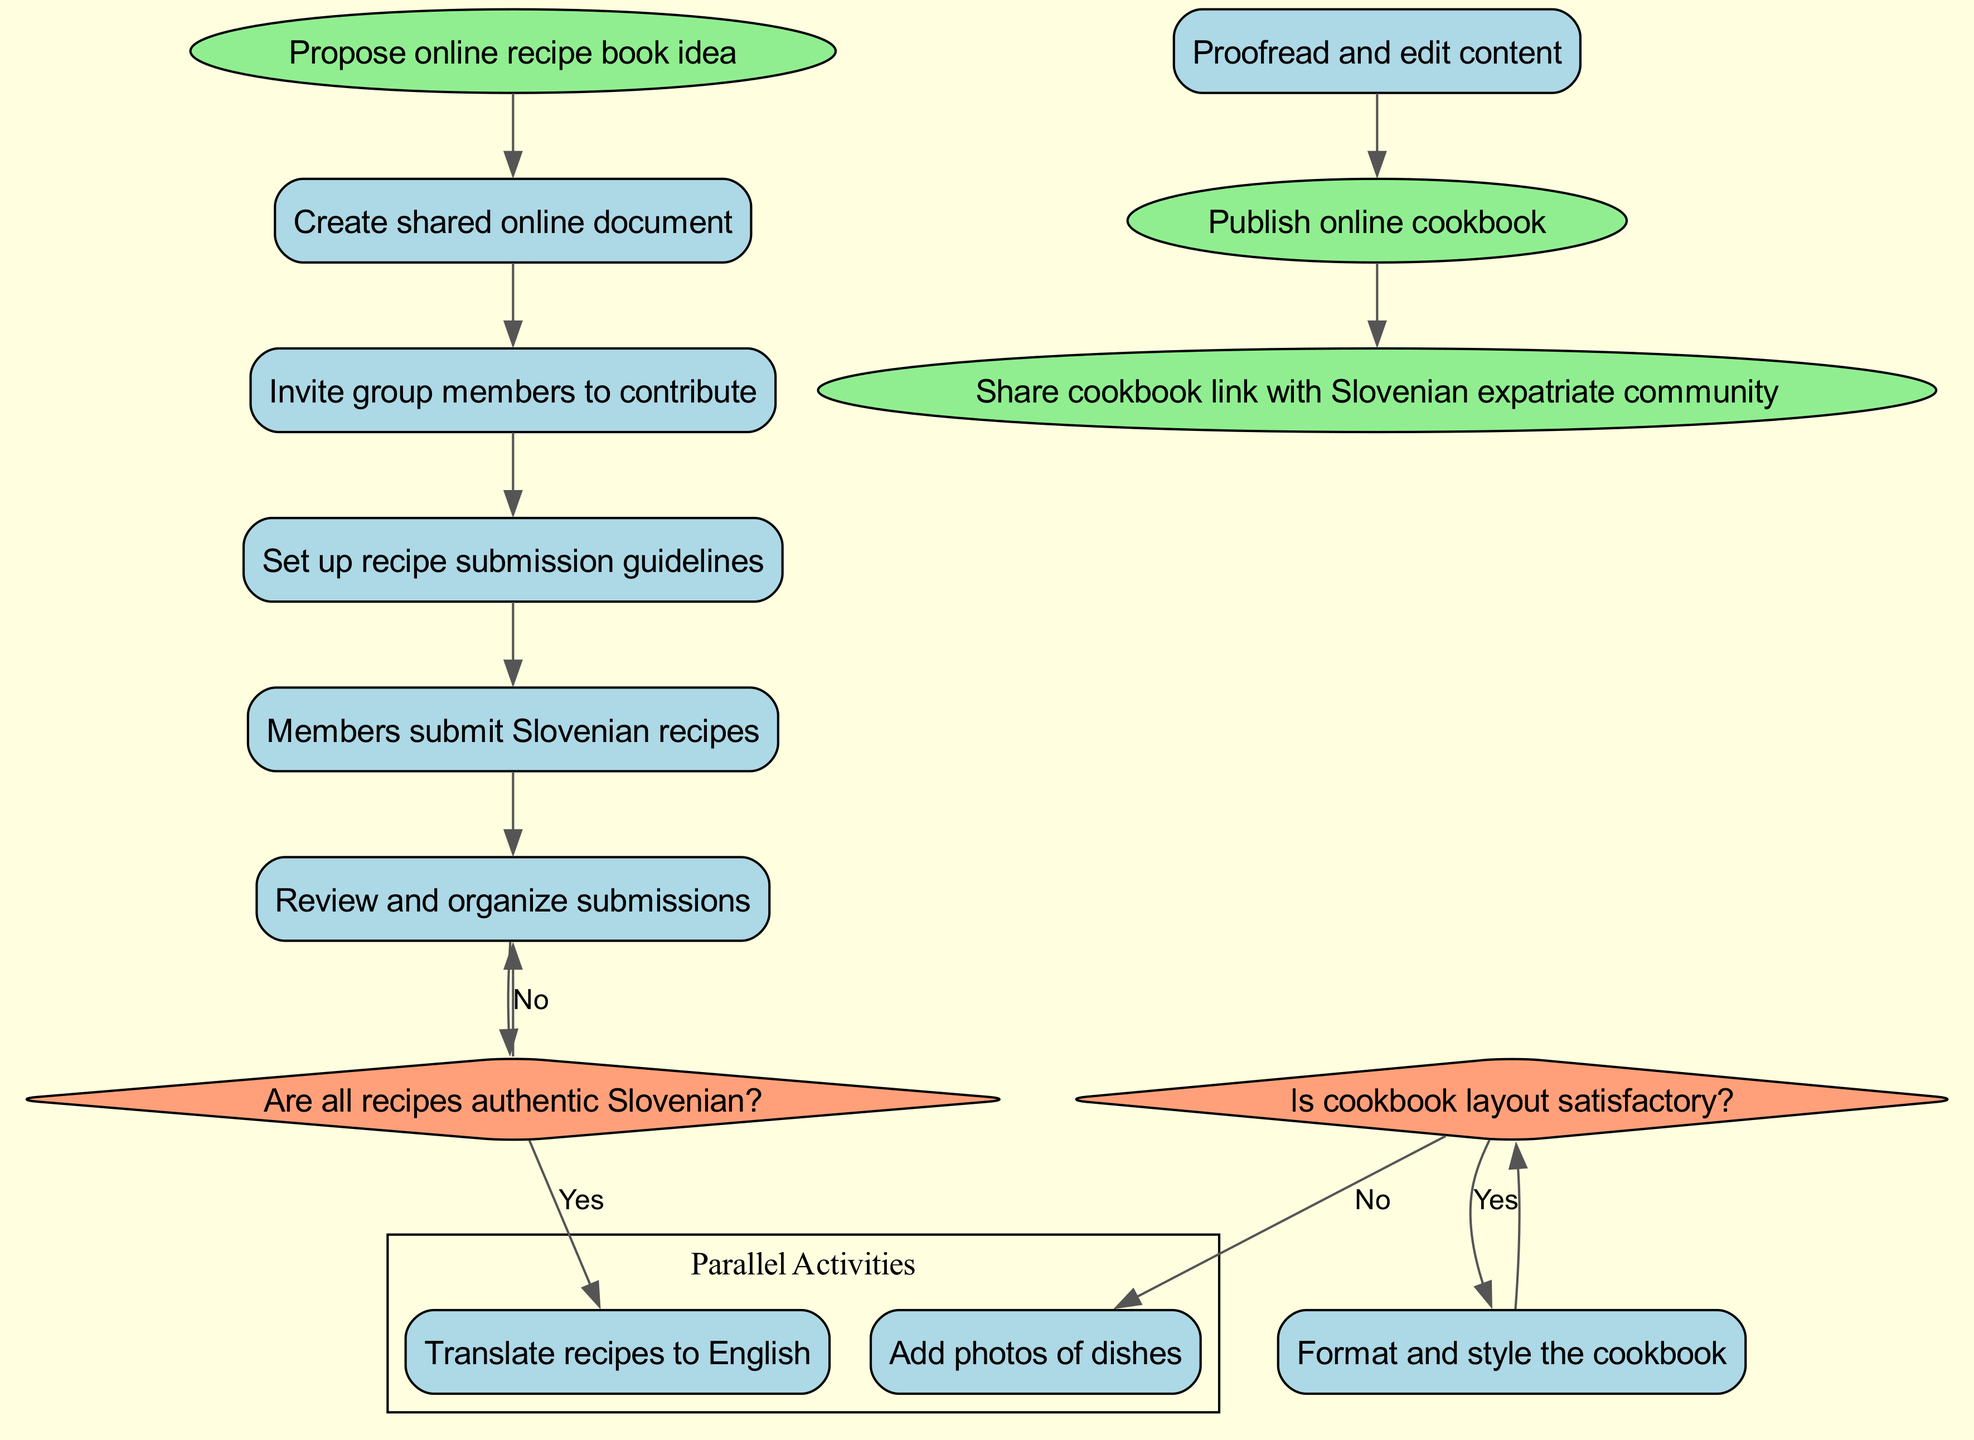What is the initial step in the diagram? The diagram starts with the initial node labeled "Propose online recipe book idea," indicating the first activity that initiates the process.
Answer: Propose online recipe book idea How many activities are listed in the diagram? The diagram includes a total of nine activities, which detail the various steps involved in setting up the recipe book, starting from creating a document to proofreading the content.
Answer: Nine What decision follows after members submit Slovenian recipes? After the recipe submissions, the decision point is "Are all recipes authentic Slovenian?" which determines whether to continue or request modifications based on authenticity.
Answer: Are all recipes authentic Slovenian? What are the two parallel activities in the diagram? The parallel activities are "Add photos of dishes" and "Translate recipes to English," indicating that these steps can be performed simultaneously during the process of creating the cookbook.
Answer: Add photos of dishes, Translate recipes to English How are the final nodes connected to the last activity? The final activities lead from the last listed activity "Proofread and edit content" to "Publish online cookbook," followed by a connection to "Share cookbook link with Slovenian expatriate community," showing the final steps before sharing the completed work.
Answer: Publish online cookbook, Share cookbook link with Slovenian expatriate community What happens if the cookbook layout is not satisfactory? If the layout is deemed unsatisfactory, the process will go back to "Adjust formatting," suggesting a review and modification of the cookbook's design before finalization.
Answer: Adjust formatting Which activity comes right before the decision about the cookbook layout? The activity that precedes the layout decision is "Format and style the cookbook," indicating the need to prepare the cookbook's visual presentation before evaluating its satisfaction.
Answer: Format and style the cookbook What decision affects the recipe validity? The decision that affects recipe validity is "Are all recipes authentic Slovenian?", which assesses the authenticity of the submitted recipes and can result in modifications if needed.
Answer: Are all recipes authentic Slovenian? 